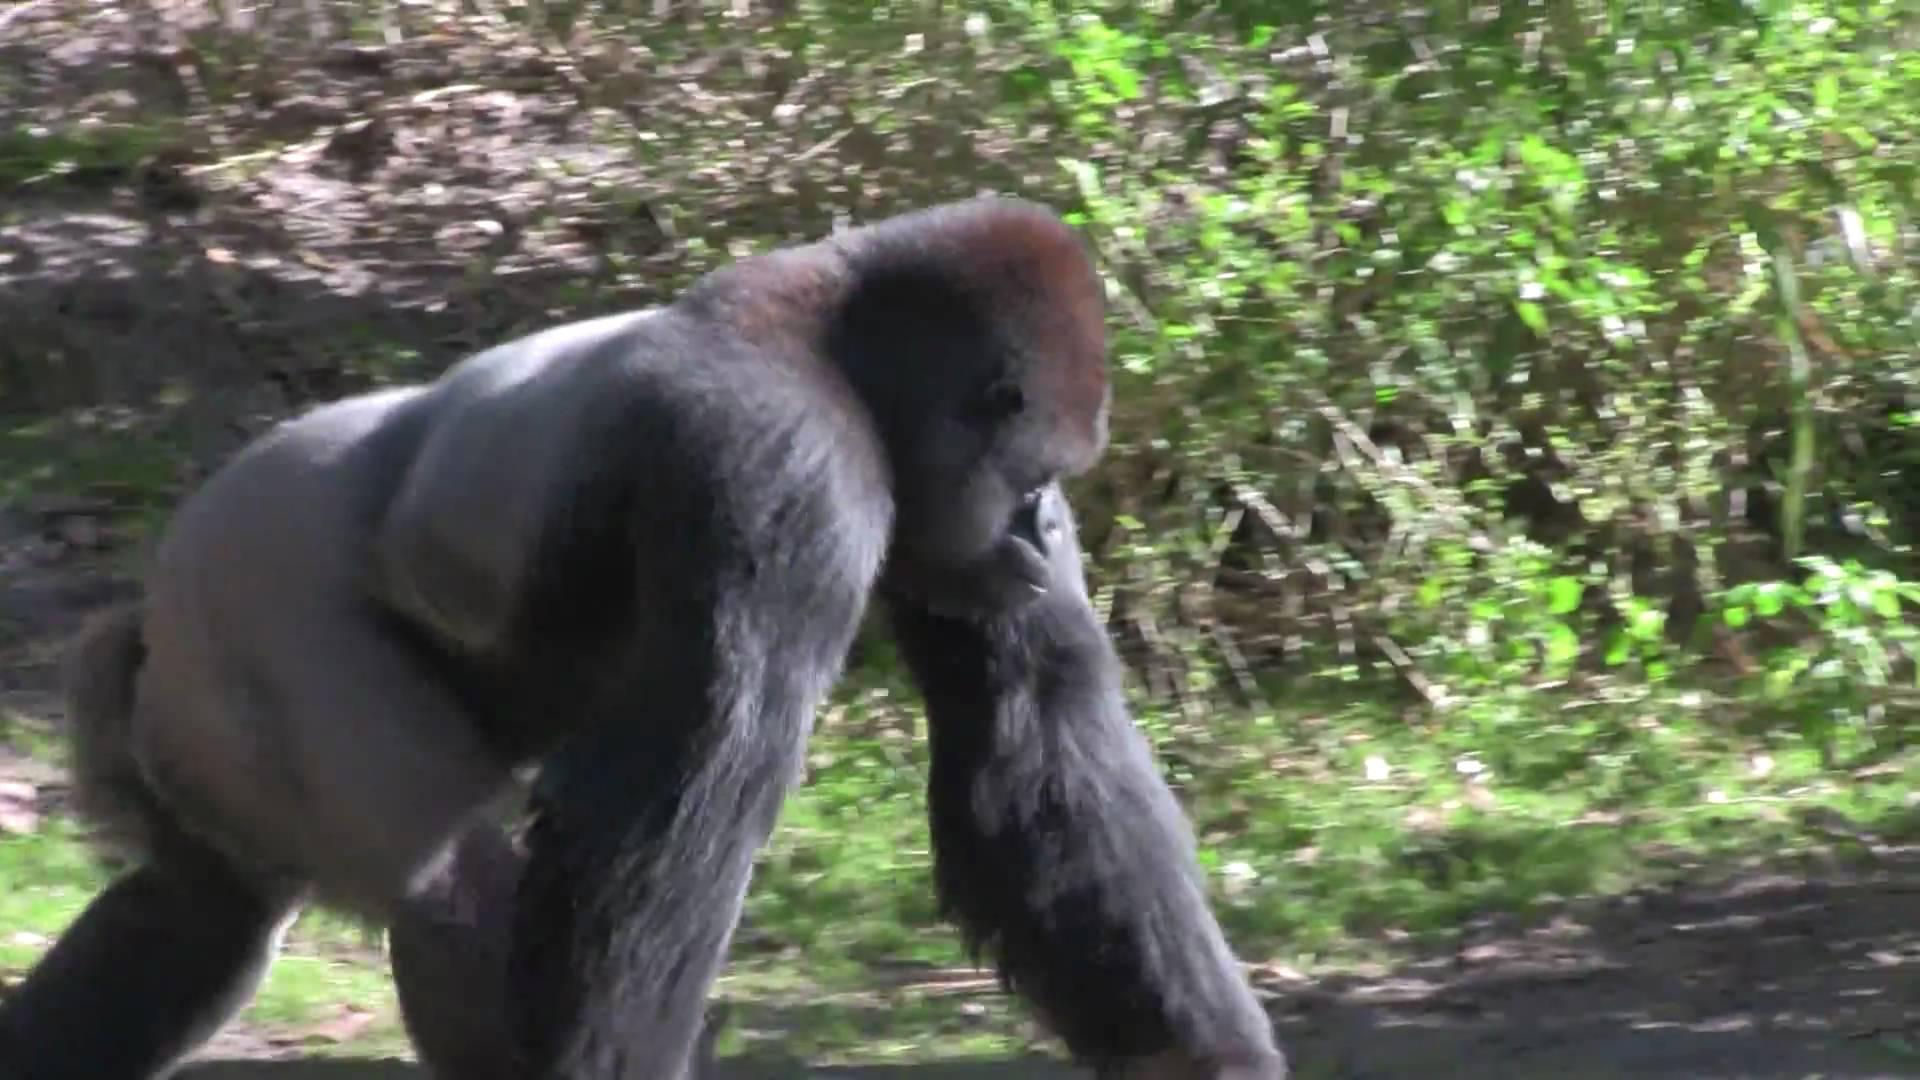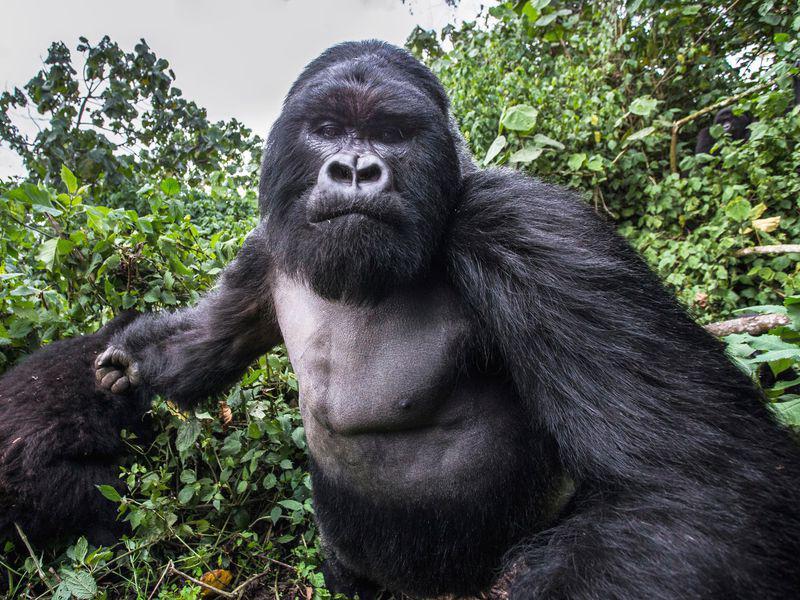The first image is the image on the left, the second image is the image on the right. For the images displayed, is the sentence "There is visible sky in one of the images." factually correct? Answer yes or no. Yes. 